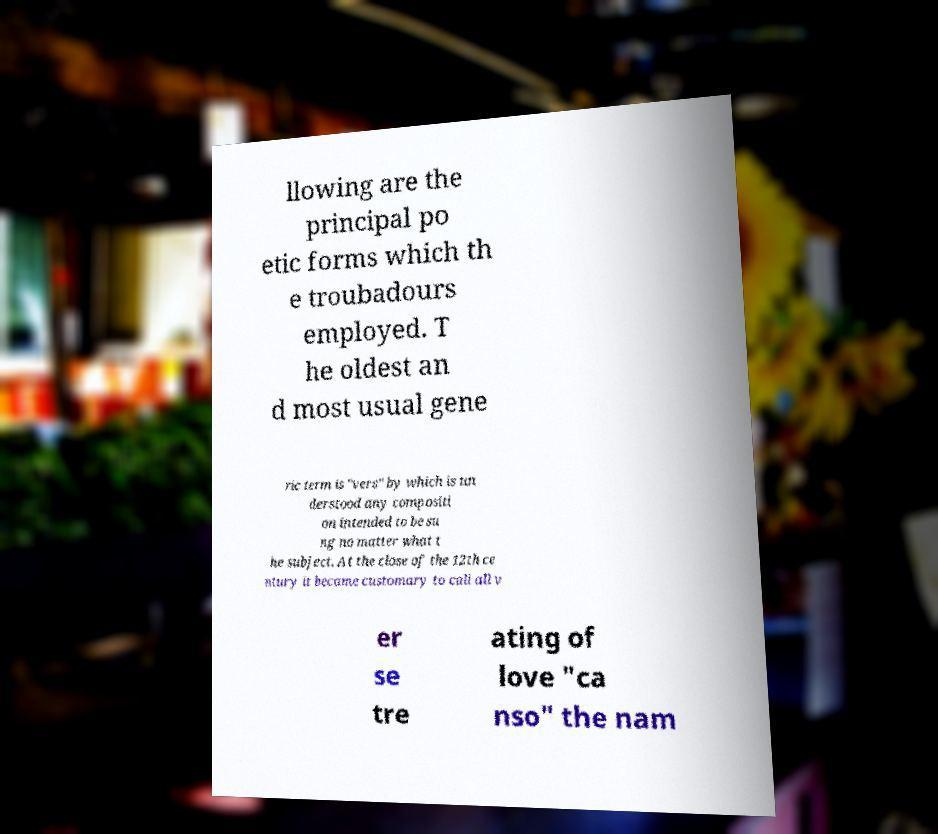Please read and relay the text visible in this image. What does it say? llowing are the principal po etic forms which th e troubadours employed. T he oldest an d most usual gene ric term is "vers" by which is un derstood any compositi on intended to be su ng no matter what t he subject. At the close of the 12th ce ntury it became customary to call all v er se tre ating of love "ca nso" the nam 